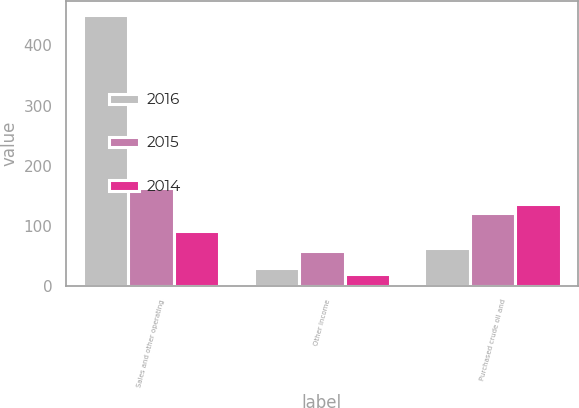<chart> <loc_0><loc_0><loc_500><loc_500><stacked_bar_chart><ecel><fcel>Sales and other operating<fcel>Other income<fcel>Purchased crude oil and<nl><fcel>2016<fcel>451<fcel>29<fcel>62<nl><fcel>2015<fcel>162<fcel>58<fcel>121<nl><fcel>2014<fcel>91.5<fcel>20<fcel>136<nl></chart> 